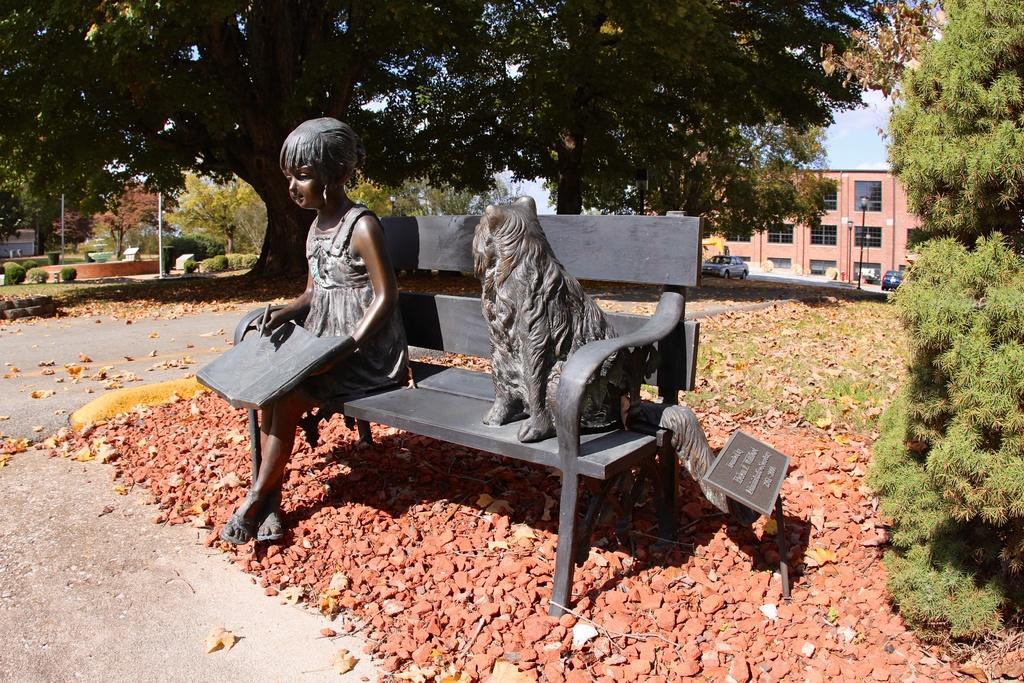In one or two sentences, can you explain what this image depicts? This is the picture where we have an idol of a girl holding a book and a dog on the sofa and behind them there is a building and some plants around. 